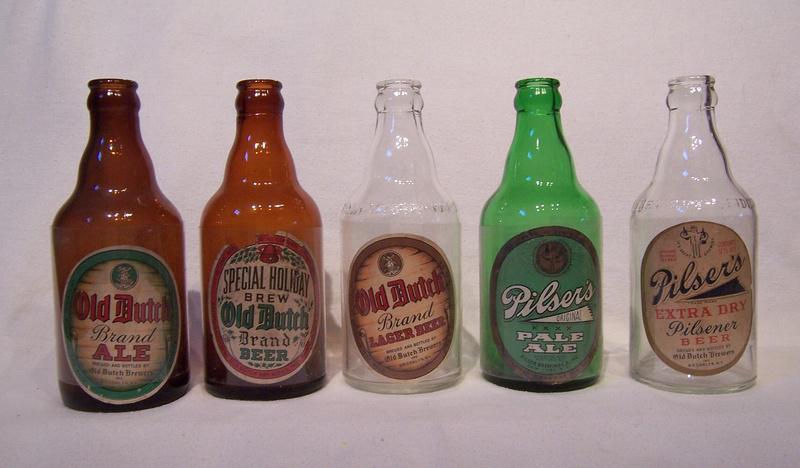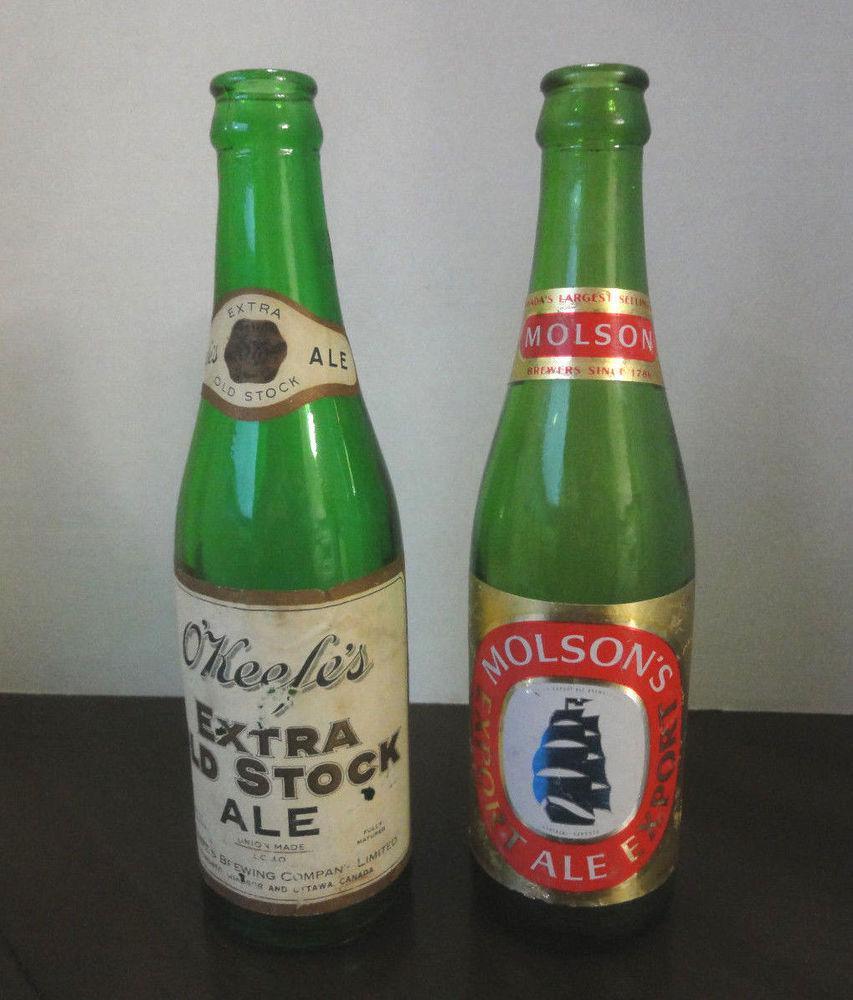The first image is the image on the left, the second image is the image on the right. Assess this claim about the two images: "An image contains exactly two bottles, both green and the same height.". Correct or not? Answer yes or no. Yes. The first image is the image on the left, the second image is the image on the right. Examine the images to the left and right. Is the description "The image on the right shows two green glass bottles" accurate? Answer yes or no. Yes. 